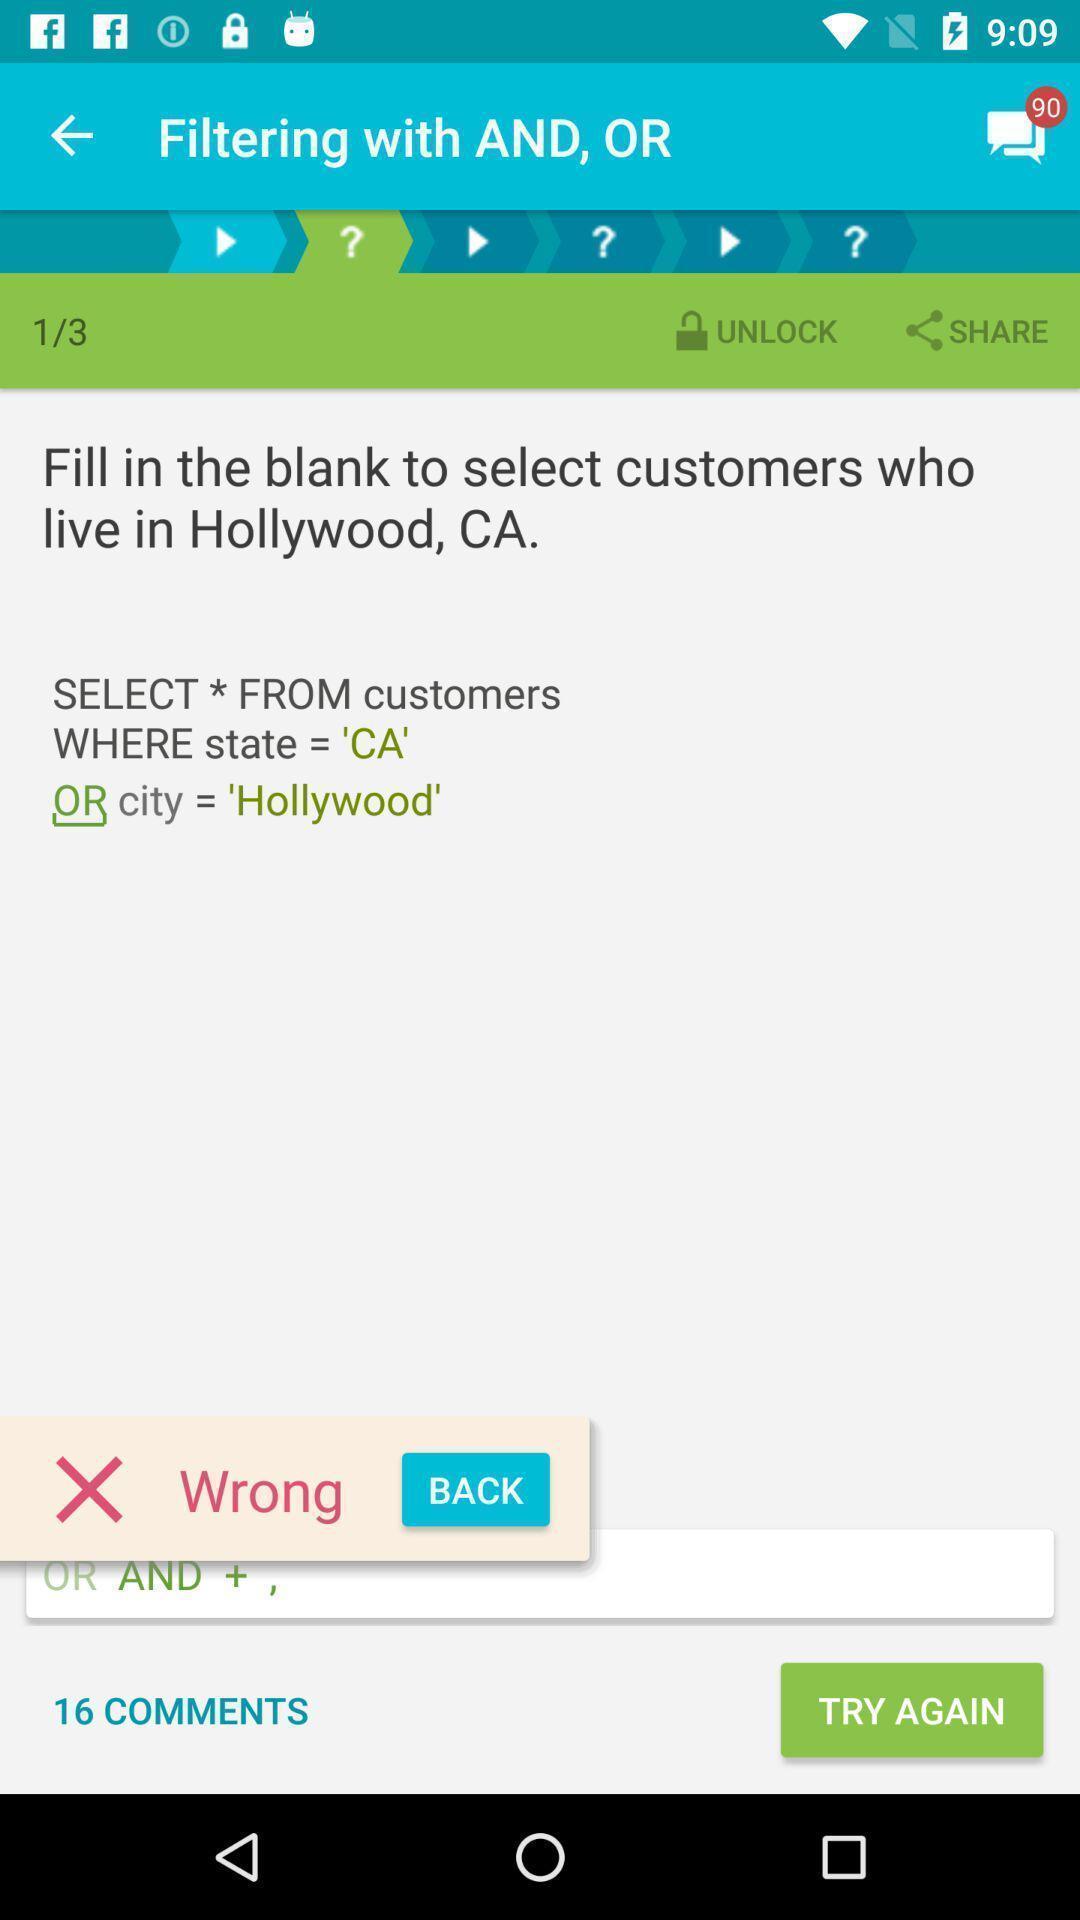What can you discern from this picture? Page of a database learning app with sql code. 